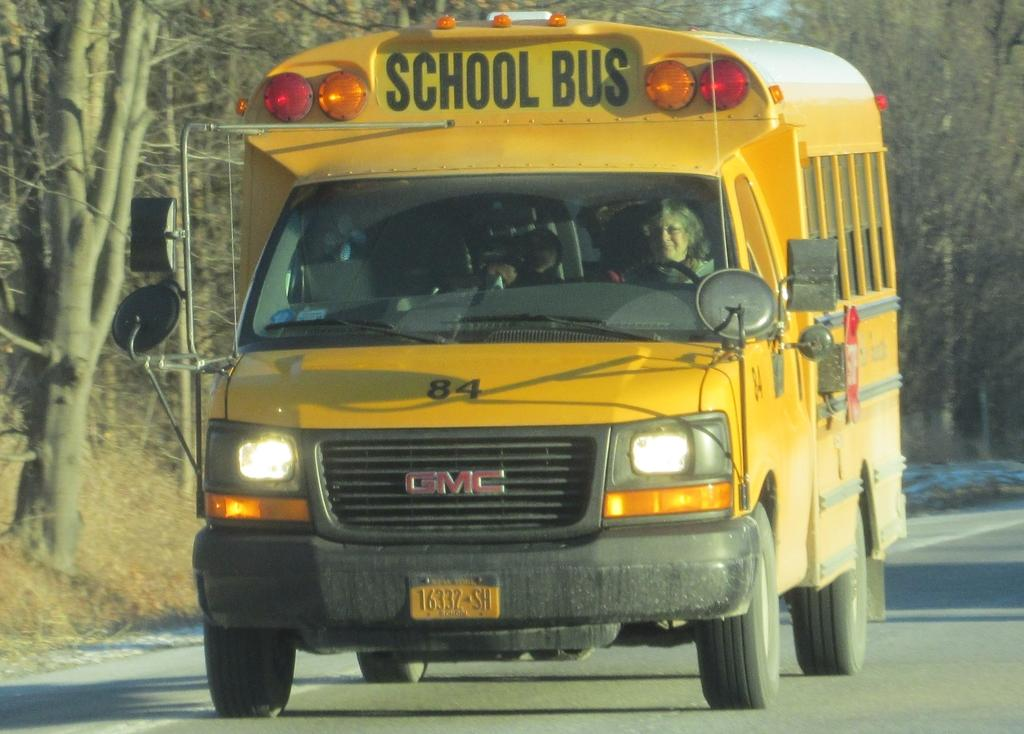Provide a one-sentence caption for the provided image. 16322SH reads the license plate of this school bus. 